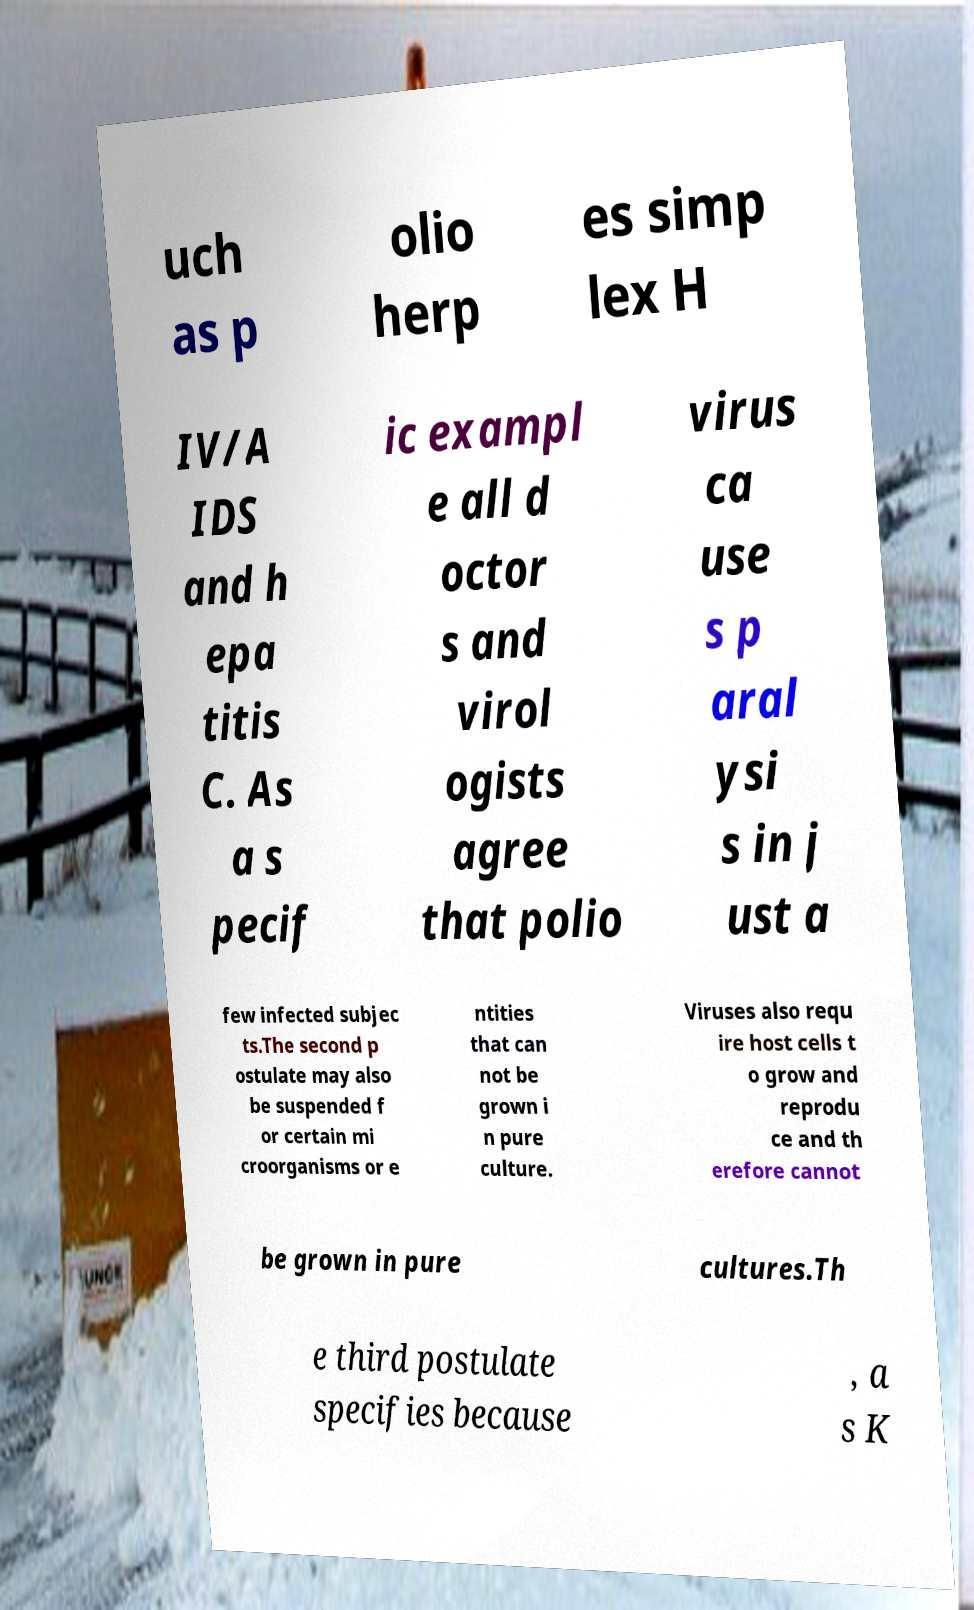Can you accurately transcribe the text from the provided image for me? uch as p olio herp es simp lex H IV/A IDS and h epa titis C. As a s pecif ic exampl e all d octor s and virol ogists agree that polio virus ca use s p aral ysi s in j ust a few infected subjec ts.The second p ostulate may also be suspended f or certain mi croorganisms or e ntities that can not be grown i n pure culture. Viruses also requ ire host cells t o grow and reprodu ce and th erefore cannot be grown in pure cultures.Th e third postulate specifies because , a s K 